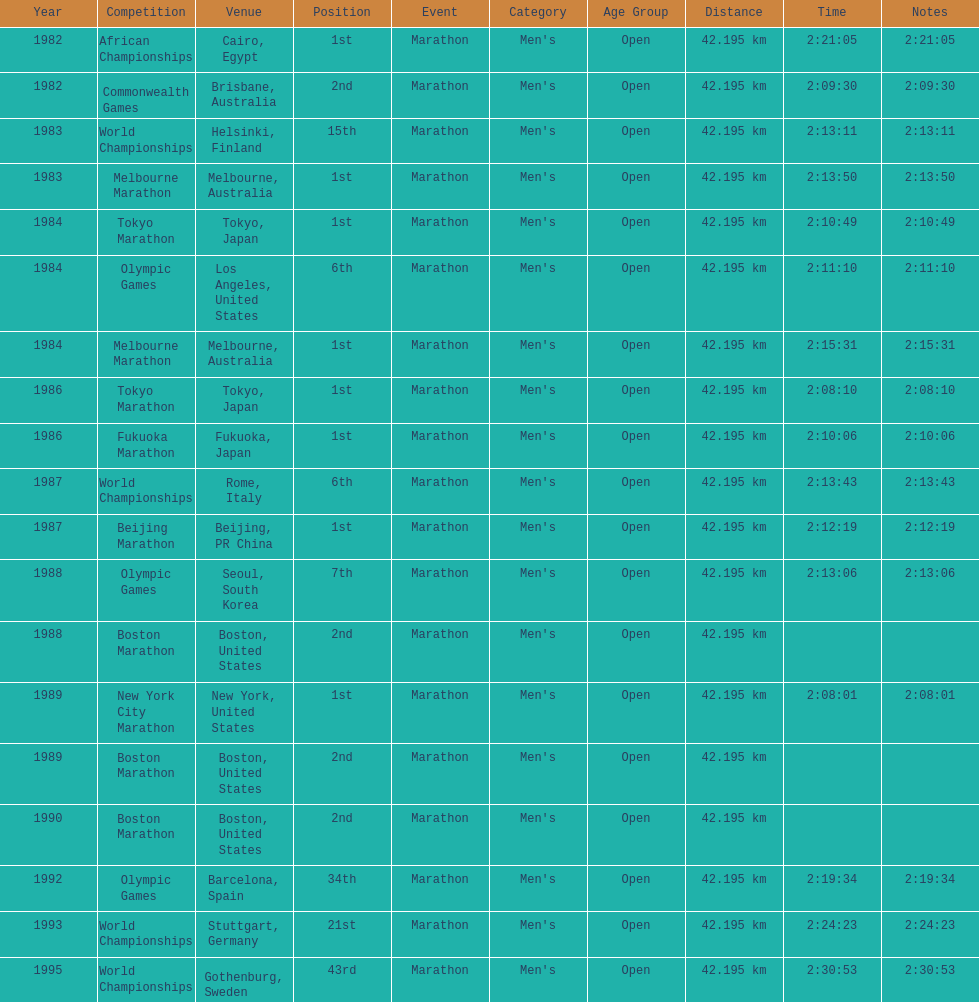Which competition is listed the most in this chart? World Championships. Could you help me parse every detail presented in this table? {'header': ['Year', 'Competition', 'Venue', 'Position', 'Event', 'Category', 'Age Group', 'Distance', 'Time', 'Notes'], 'rows': [['1982', 'African Championships', 'Cairo, Egypt', '1st', 'Marathon', "Men's", 'Open', '42.195 km', '2:21:05', '2:21:05'], ['1982', 'Commonwealth Games', 'Brisbane, Australia', '2nd', 'Marathon', "Men's", 'Open', '42.195 km', '2:09:30', '2:09:30'], ['1983', 'World Championships', 'Helsinki, Finland', '15th', 'Marathon', "Men's", 'Open', '42.195 km', '2:13:11', '2:13:11'], ['1983', 'Melbourne Marathon', 'Melbourne, Australia', '1st', 'Marathon', "Men's", 'Open', '42.195 km', '2:13:50', '2:13:50'], ['1984', 'Tokyo Marathon', 'Tokyo, Japan', '1st', 'Marathon', "Men's", 'Open', '42.195 km', '2:10:49', '2:10:49'], ['1984', 'Olympic Games', 'Los Angeles, United States', '6th', 'Marathon', "Men's", 'Open', '42.195 km', '2:11:10', '2:11:10'], ['1984', 'Melbourne Marathon', 'Melbourne, Australia', '1st', 'Marathon', "Men's", 'Open', '42.195 km', '2:15:31', '2:15:31'], ['1986', 'Tokyo Marathon', 'Tokyo, Japan', '1st', 'Marathon', "Men's", 'Open', '42.195 km', '2:08:10', '2:08:10'], ['1986', 'Fukuoka Marathon', 'Fukuoka, Japan', '1st', 'Marathon', "Men's", 'Open', '42.195 km', '2:10:06', '2:10:06'], ['1987', 'World Championships', 'Rome, Italy', '6th', 'Marathon', "Men's", 'Open', '42.195 km', '2:13:43', '2:13:43'], ['1987', 'Beijing Marathon', 'Beijing, PR China', '1st', 'Marathon', "Men's", 'Open', '42.195 km', '2:12:19', '2:12:19'], ['1988', 'Olympic Games', 'Seoul, South Korea', '7th', 'Marathon', "Men's", 'Open', '42.195 km', '2:13:06', '2:13:06'], ['1988', 'Boston Marathon', 'Boston, United States', '2nd', 'Marathon', "Men's", 'Open', '42.195 km', '', ''], ['1989', 'New York City Marathon', 'New York, United States', '1st', 'Marathon', "Men's", 'Open', '42.195 km', '2:08:01', '2:08:01'], ['1989', 'Boston Marathon', 'Boston, United States', '2nd', 'Marathon', "Men's", 'Open', '42.195 km', '', ''], ['1990', 'Boston Marathon', 'Boston, United States', '2nd', 'Marathon', "Men's", 'Open', '42.195 km', '', ''], ['1992', 'Olympic Games', 'Barcelona, Spain', '34th', 'Marathon', "Men's", 'Open', '42.195 km', '2:19:34', '2:19:34'], ['1993', 'World Championships', 'Stuttgart, Germany', '21st', 'Marathon', "Men's", 'Open', '42.195 km', '2:24:23', '2:24:23'], ['1995', 'World Championships', 'Gothenburg, Sweden', '43rd', 'Marathon', "Men's", 'Open', '42.195 km', '2:30:53', '2:30:53']]} 